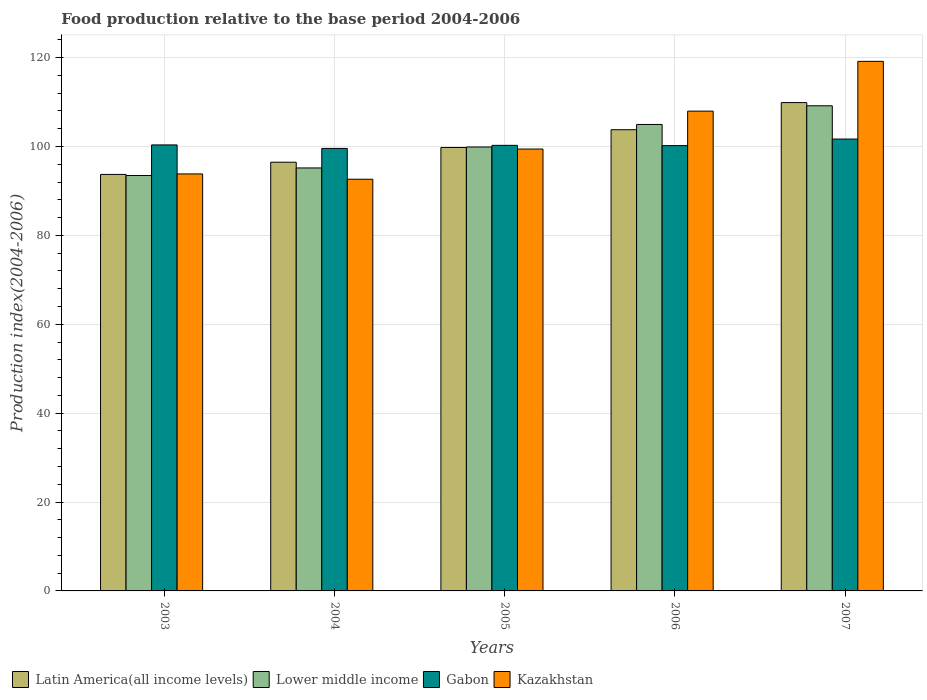How many different coloured bars are there?
Provide a short and direct response. 4. How many groups of bars are there?
Make the answer very short. 5. Are the number of bars per tick equal to the number of legend labels?
Offer a terse response. Yes. Are the number of bars on each tick of the X-axis equal?
Your answer should be compact. Yes. What is the food production index in Latin America(all income levels) in 2003?
Keep it short and to the point. 93.71. Across all years, what is the maximum food production index in Kazakhstan?
Provide a short and direct response. 119.15. Across all years, what is the minimum food production index in Gabon?
Offer a very short reply. 99.56. In which year was the food production index in Kazakhstan maximum?
Your answer should be compact. 2007. In which year was the food production index in Kazakhstan minimum?
Ensure brevity in your answer.  2004. What is the total food production index in Lower middle income in the graph?
Offer a terse response. 502.62. What is the difference between the food production index in Gabon in 2003 and that in 2005?
Keep it short and to the point. 0.1. What is the difference between the food production index in Latin America(all income levels) in 2005 and the food production index in Lower middle income in 2004?
Keep it short and to the point. 4.61. What is the average food production index in Latin America(all income levels) per year?
Make the answer very short. 100.72. In the year 2005, what is the difference between the food production index in Kazakhstan and food production index in Lower middle income?
Give a very brief answer. -0.46. What is the ratio of the food production index in Gabon in 2004 to that in 2007?
Your answer should be very brief. 0.98. Is the food production index in Lower middle income in 2004 less than that in 2005?
Make the answer very short. Yes. What is the difference between the highest and the second highest food production index in Kazakhstan?
Make the answer very short. 11.2. What is the difference between the highest and the lowest food production index in Kazakhstan?
Your response must be concise. 26.52. Is the sum of the food production index in Gabon in 2003 and 2005 greater than the maximum food production index in Latin America(all income levels) across all years?
Your response must be concise. Yes. Is it the case that in every year, the sum of the food production index in Latin America(all income levels) and food production index in Lower middle income is greater than the sum of food production index in Kazakhstan and food production index in Gabon?
Offer a terse response. No. What does the 4th bar from the left in 2005 represents?
Your answer should be compact. Kazakhstan. What does the 3rd bar from the right in 2004 represents?
Your response must be concise. Lower middle income. How many bars are there?
Provide a succinct answer. 20. Are all the bars in the graph horizontal?
Your response must be concise. No. How are the legend labels stacked?
Your answer should be very brief. Horizontal. What is the title of the graph?
Offer a terse response. Food production relative to the base period 2004-2006. Does "Guyana" appear as one of the legend labels in the graph?
Ensure brevity in your answer.  No. What is the label or title of the X-axis?
Ensure brevity in your answer.  Years. What is the label or title of the Y-axis?
Give a very brief answer. Production index(2004-2006). What is the Production index(2004-2006) of Latin America(all income levels) in 2003?
Provide a short and direct response. 93.71. What is the Production index(2004-2006) in Lower middle income in 2003?
Make the answer very short. 93.47. What is the Production index(2004-2006) of Gabon in 2003?
Your answer should be compact. 100.35. What is the Production index(2004-2006) of Kazakhstan in 2003?
Your answer should be very brief. 93.82. What is the Production index(2004-2006) of Latin America(all income levels) in 2004?
Provide a succinct answer. 96.46. What is the Production index(2004-2006) of Lower middle income in 2004?
Your answer should be very brief. 95.17. What is the Production index(2004-2006) in Gabon in 2004?
Your response must be concise. 99.56. What is the Production index(2004-2006) in Kazakhstan in 2004?
Your answer should be very brief. 92.63. What is the Production index(2004-2006) of Latin America(all income levels) in 2005?
Your answer should be very brief. 99.77. What is the Production index(2004-2006) in Lower middle income in 2005?
Provide a succinct answer. 99.88. What is the Production index(2004-2006) of Gabon in 2005?
Offer a terse response. 100.25. What is the Production index(2004-2006) of Kazakhstan in 2005?
Your response must be concise. 99.42. What is the Production index(2004-2006) of Latin America(all income levels) in 2006?
Provide a succinct answer. 103.77. What is the Production index(2004-2006) in Lower middle income in 2006?
Offer a terse response. 104.95. What is the Production index(2004-2006) of Gabon in 2006?
Your answer should be very brief. 100.19. What is the Production index(2004-2006) in Kazakhstan in 2006?
Offer a very short reply. 107.95. What is the Production index(2004-2006) of Latin America(all income levels) in 2007?
Ensure brevity in your answer.  109.87. What is the Production index(2004-2006) of Lower middle income in 2007?
Keep it short and to the point. 109.15. What is the Production index(2004-2006) in Gabon in 2007?
Offer a terse response. 101.67. What is the Production index(2004-2006) of Kazakhstan in 2007?
Provide a succinct answer. 119.15. Across all years, what is the maximum Production index(2004-2006) in Latin America(all income levels)?
Ensure brevity in your answer.  109.87. Across all years, what is the maximum Production index(2004-2006) of Lower middle income?
Make the answer very short. 109.15. Across all years, what is the maximum Production index(2004-2006) in Gabon?
Provide a succinct answer. 101.67. Across all years, what is the maximum Production index(2004-2006) of Kazakhstan?
Your answer should be compact. 119.15. Across all years, what is the minimum Production index(2004-2006) in Latin America(all income levels)?
Keep it short and to the point. 93.71. Across all years, what is the minimum Production index(2004-2006) in Lower middle income?
Offer a very short reply. 93.47. Across all years, what is the minimum Production index(2004-2006) of Gabon?
Your response must be concise. 99.56. Across all years, what is the minimum Production index(2004-2006) of Kazakhstan?
Ensure brevity in your answer.  92.63. What is the total Production index(2004-2006) of Latin America(all income levels) in the graph?
Make the answer very short. 503.59. What is the total Production index(2004-2006) in Lower middle income in the graph?
Offer a terse response. 502.62. What is the total Production index(2004-2006) in Gabon in the graph?
Your response must be concise. 502.02. What is the total Production index(2004-2006) in Kazakhstan in the graph?
Provide a succinct answer. 512.97. What is the difference between the Production index(2004-2006) in Latin America(all income levels) in 2003 and that in 2004?
Keep it short and to the point. -2.74. What is the difference between the Production index(2004-2006) in Gabon in 2003 and that in 2004?
Your answer should be compact. 0.79. What is the difference between the Production index(2004-2006) of Kazakhstan in 2003 and that in 2004?
Your response must be concise. 1.19. What is the difference between the Production index(2004-2006) in Latin America(all income levels) in 2003 and that in 2005?
Give a very brief answer. -6.06. What is the difference between the Production index(2004-2006) of Lower middle income in 2003 and that in 2005?
Ensure brevity in your answer.  -6.41. What is the difference between the Production index(2004-2006) in Latin America(all income levels) in 2003 and that in 2006?
Offer a terse response. -10.06. What is the difference between the Production index(2004-2006) of Lower middle income in 2003 and that in 2006?
Your response must be concise. -11.49. What is the difference between the Production index(2004-2006) in Gabon in 2003 and that in 2006?
Give a very brief answer. 0.16. What is the difference between the Production index(2004-2006) in Kazakhstan in 2003 and that in 2006?
Provide a succinct answer. -14.13. What is the difference between the Production index(2004-2006) of Latin America(all income levels) in 2003 and that in 2007?
Offer a terse response. -16.16. What is the difference between the Production index(2004-2006) in Lower middle income in 2003 and that in 2007?
Keep it short and to the point. -15.69. What is the difference between the Production index(2004-2006) of Gabon in 2003 and that in 2007?
Ensure brevity in your answer.  -1.32. What is the difference between the Production index(2004-2006) of Kazakhstan in 2003 and that in 2007?
Provide a succinct answer. -25.33. What is the difference between the Production index(2004-2006) in Latin America(all income levels) in 2004 and that in 2005?
Provide a short and direct response. -3.32. What is the difference between the Production index(2004-2006) of Lower middle income in 2004 and that in 2005?
Provide a short and direct response. -4.71. What is the difference between the Production index(2004-2006) in Gabon in 2004 and that in 2005?
Provide a short and direct response. -0.69. What is the difference between the Production index(2004-2006) of Kazakhstan in 2004 and that in 2005?
Offer a terse response. -6.79. What is the difference between the Production index(2004-2006) in Latin America(all income levels) in 2004 and that in 2006?
Your answer should be compact. -7.31. What is the difference between the Production index(2004-2006) in Lower middle income in 2004 and that in 2006?
Provide a short and direct response. -9.79. What is the difference between the Production index(2004-2006) in Gabon in 2004 and that in 2006?
Keep it short and to the point. -0.63. What is the difference between the Production index(2004-2006) in Kazakhstan in 2004 and that in 2006?
Offer a very short reply. -15.32. What is the difference between the Production index(2004-2006) in Latin America(all income levels) in 2004 and that in 2007?
Provide a short and direct response. -13.42. What is the difference between the Production index(2004-2006) in Lower middle income in 2004 and that in 2007?
Give a very brief answer. -13.99. What is the difference between the Production index(2004-2006) of Gabon in 2004 and that in 2007?
Provide a succinct answer. -2.11. What is the difference between the Production index(2004-2006) in Kazakhstan in 2004 and that in 2007?
Make the answer very short. -26.52. What is the difference between the Production index(2004-2006) of Latin America(all income levels) in 2005 and that in 2006?
Offer a very short reply. -4. What is the difference between the Production index(2004-2006) of Lower middle income in 2005 and that in 2006?
Ensure brevity in your answer.  -5.07. What is the difference between the Production index(2004-2006) of Gabon in 2005 and that in 2006?
Provide a succinct answer. 0.06. What is the difference between the Production index(2004-2006) of Kazakhstan in 2005 and that in 2006?
Ensure brevity in your answer.  -8.53. What is the difference between the Production index(2004-2006) of Latin America(all income levels) in 2005 and that in 2007?
Your answer should be compact. -10.1. What is the difference between the Production index(2004-2006) of Lower middle income in 2005 and that in 2007?
Offer a very short reply. -9.27. What is the difference between the Production index(2004-2006) in Gabon in 2005 and that in 2007?
Your answer should be very brief. -1.42. What is the difference between the Production index(2004-2006) in Kazakhstan in 2005 and that in 2007?
Offer a very short reply. -19.73. What is the difference between the Production index(2004-2006) of Latin America(all income levels) in 2006 and that in 2007?
Provide a short and direct response. -6.1. What is the difference between the Production index(2004-2006) in Lower middle income in 2006 and that in 2007?
Ensure brevity in your answer.  -4.2. What is the difference between the Production index(2004-2006) in Gabon in 2006 and that in 2007?
Ensure brevity in your answer.  -1.48. What is the difference between the Production index(2004-2006) of Kazakhstan in 2006 and that in 2007?
Offer a terse response. -11.2. What is the difference between the Production index(2004-2006) of Latin America(all income levels) in 2003 and the Production index(2004-2006) of Lower middle income in 2004?
Offer a terse response. -1.45. What is the difference between the Production index(2004-2006) of Latin America(all income levels) in 2003 and the Production index(2004-2006) of Gabon in 2004?
Your answer should be very brief. -5.85. What is the difference between the Production index(2004-2006) of Latin America(all income levels) in 2003 and the Production index(2004-2006) of Kazakhstan in 2004?
Ensure brevity in your answer.  1.08. What is the difference between the Production index(2004-2006) of Lower middle income in 2003 and the Production index(2004-2006) of Gabon in 2004?
Keep it short and to the point. -6.09. What is the difference between the Production index(2004-2006) in Lower middle income in 2003 and the Production index(2004-2006) in Kazakhstan in 2004?
Provide a short and direct response. 0.84. What is the difference between the Production index(2004-2006) of Gabon in 2003 and the Production index(2004-2006) of Kazakhstan in 2004?
Your response must be concise. 7.72. What is the difference between the Production index(2004-2006) of Latin America(all income levels) in 2003 and the Production index(2004-2006) of Lower middle income in 2005?
Provide a short and direct response. -6.17. What is the difference between the Production index(2004-2006) in Latin America(all income levels) in 2003 and the Production index(2004-2006) in Gabon in 2005?
Your response must be concise. -6.54. What is the difference between the Production index(2004-2006) in Latin America(all income levels) in 2003 and the Production index(2004-2006) in Kazakhstan in 2005?
Your response must be concise. -5.71. What is the difference between the Production index(2004-2006) in Lower middle income in 2003 and the Production index(2004-2006) in Gabon in 2005?
Make the answer very short. -6.78. What is the difference between the Production index(2004-2006) in Lower middle income in 2003 and the Production index(2004-2006) in Kazakhstan in 2005?
Offer a terse response. -5.95. What is the difference between the Production index(2004-2006) of Gabon in 2003 and the Production index(2004-2006) of Kazakhstan in 2005?
Your response must be concise. 0.93. What is the difference between the Production index(2004-2006) in Latin America(all income levels) in 2003 and the Production index(2004-2006) in Lower middle income in 2006?
Your answer should be very brief. -11.24. What is the difference between the Production index(2004-2006) of Latin America(all income levels) in 2003 and the Production index(2004-2006) of Gabon in 2006?
Your response must be concise. -6.48. What is the difference between the Production index(2004-2006) of Latin America(all income levels) in 2003 and the Production index(2004-2006) of Kazakhstan in 2006?
Provide a short and direct response. -14.24. What is the difference between the Production index(2004-2006) in Lower middle income in 2003 and the Production index(2004-2006) in Gabon in 2006?
Your answer should be compact. -6.72. What is the difference between the Production index(2004-2006) in Lower middle income in 2003 and the Production index(2004-2006) in Kazakhstan in 2006?
Your answer should be very brief. -14.48. What is the difference between the Production index(2004-2006) of Gabon in 2003 and the Production index(2004-2006) of Kazakhstan in 2006?
Give a very brief answer. -7.6. What is the difference between the Production index(2004-2006) of Latin America(all income levels) in 2003 and the Production index(2004-2006) of Lower middle income in 2007?
Your answer should be very brief. -15.44. What is the difference between the Production index(2004-2006) in Latin America(all income levels) in 2003 and the Production index(2004-2006) in Gabon in 2007?
Keep it short and to the point. -7.96. What is the difference between the Production index(2004-2006) of Latin America(all income levels) in 2003 and the Production index(2004-2006) of Kazakhstan in 2007?
Offer a very short reply. -25.44. What is the difference between the Production index(2004-2006) in Lower middle income in 2003 and the Production index(2004-2006) in Gabon in 2007?
Provide a succinct answer. -8.2. What is the difference between the Production index(2004-2006) of Lower middle income in 2003 and the Production index(2004-2006) of Kazakhstan in 2007?
Provide a short and direct response. -25.68. What is the difference between the Production index(2004-2006) in Gabon in 2003 and the Production index(2004-2006) in Kazakhstan in 2007?
Provide a succinct answer. -18.8. What is the difference between the Production index(2004-2006) in Latin America(all income levels) in 2004 and the Production index(2004-2006) in Lower middle income in 2005?
Offer a very short reply. -3.42. What is the difference between the Production index(2004-2006) in Latin America(all income levels) in 2004 and the Production index(2004-2006) in Gabon in 2005?
Provide a short and direct response. -3.79. What is the difference between the Production index(2004-2006) in Latin America(all income levels) in 2004 and the Production index(2004-2006) in Kazakhstan in 2005?
Ensure brevity in your answer.  -2.96. What is the difference between the Production index(2004-2006) in Lower middle income in 2004 and the Production index(2004-2006) in Gabon in 2005?
Your answer should be very brief. -5.08. What is the difference between the Production index(2004-2006) of Lower middle income in 2004 and the Production index(2004-2006) of Kazakhstan in 2005?
Offer a terse response. -4.25. What is the difference between the Production index(2004-2006) in Gabon in 2004 and the Production index(2004-2006) in Kazakhstan in 2005?
Give a very brief answer. 0.14. What is the difference between the Production index(2004-2006) in Latin America(all income levels) in 2004 and the Production index(2004-2006) in Lower middle income in 2006?
Give a very brief answer. -8.5. What is the difference between the Production index(2004-2006) in Latin America(all income levels) in 2004 and the Production index(2004-2006) in Gabon in 2006?
Give a very brief answer. -3.73. What is the difference between the Production index(2004-2006) in Latin America(all income levels) in 2004 and the Production index(2004-2006) in Kazakhstan in 2006?
Give a very brief answer. -11.49. What is the difference between the Production index(2004-2006) in Lower middle income in 2004 and the Production index(2004-2006) in Gabon in 2006?
Provide a succinct answer. -5.02. What is the difference between the Production index(2004-2006) in Lower middle income in 2004 and the Production index(2004-2006) in Kazakhstan in 2006?
Offer a terse response. -12.78. What is the difference between the Production index(2004-2006) in Gabon in 2004 and the Production index(2004-2006) in Kazakhstan in 2006?
Keep it short and to the point. -8.39. What is the difference between the Production index(2004-2006) of Latin America(all income levels) in 2004 and the Production index(2004-2006) of Lower middle income in 2007?
Your answer should be compact. -12.7. What is the difference between the Production index(2004-2006) of Latin America(all income levels) in 2004 and the Production index(2004-2006) of Gabon in 2007?
Give a very brief answer. -5.21. What is the difference between the Production index(2004-2006) in Latin America(all income levels) in 2004 and the Production index(2004-2006) in Kazakhstan in 2007?
Offer a very short reply. -22.69. What is the difference between the Production index(2004-2006) in Lower middle income in 2004 and the Production index(2004-2006) in Gabon in 2007?
Your response must be concise. -6.5. What is the difference between the Production index(2004-2006) of Lower middle income in 2004 and the Production index(2004-2006) of Kazakhstan in 2007?
Provide a short and direct response. -23.98. What is the difference between the Production index(2004-2006) of Gabon in 2004 and the Production index(2004-2006) of Kazakhstan in 2007?
Your answer should be compact. -19.59. What is the difference between the Production index(2004-2006) of Latin America(all income levels) in 2005 and the Production index(2004-2006) of Lower middle income in 2006?
Your answer should be compact. -5.18. What is the difference between the Production index(2004-2006) in Latin America(all income levels) in 2005 and the Production index(2004-2006) in Gabon in 2006?
Keep it short and to the point. -0.42. What is the difference between the Production index(2004-2006) in Latin America(all income levels) in 2005 and the Production index(2004-2006) in Kazakhstan in 2006?
Your answer should be very brief. -8.18. What is the difference between the Production index(2004-2006) in Lower middle income in 2005 and the Production index(2004-2006) in Gabon in 2006?
Offer a very short reply. -0.31. What is the difference between the Production index(2004-2006) of Lower middle income in 2005 and the Production index(2004-2006) of Kazakhstan in 2006?
Keep it short and to the point. -8.07. What is the difference between the Production index(2004-2006) in Gabon in 2005 and the Production index(2004-2006) in Kazakhstan in 2006?
Offer a terse response. -7.7. What is the difference between the Production index(2004-2006) in Latin America(all income levels) in 2005 and the Production index(2004-2006) in Lower middle income in 2007?
Offer a terse response. -9.38. What is the difference between the Production index(2004-2006) of Latin America(all income levels) in 2005 and the Production index(2004-2006) of Gabon in 2007?
Your answer should be compact. -1.9. What is the difference between the Production index(2004-2006) of Latin America(all income levels) in 2005 and the Production index(2004-2006) of Kazakhstan in 2007?
Your answer should be compact. -19.38. What is the difference between the Production index(2004-2006) of Lower middle income in 2005 and the Production index(2004-2006) of Gabon in 2007?
Offer a terse response. -1.79. What is the difference between the Production index(2004-2006) in Lower middle income in 2005 and the Production index(2004-2006) in Kazakhstan in 2007?
Your answer should be compact. -19.27. What is the difference between the Production index(2004-2006) of Gabon in 2005 and the Production index(2004-2006) of Kazakhstan in 2007?
Your response must be concise. -18.9. What is the difference between the Production index(2004-2006) of Latin America(all income levels) in 2006 and the Production index(2004-2006) of Lower middle income in 2007?
Offer a very short reply. -5.38. What is the difference between the Production index(2004-2006) in Latin America(all income levels) in 2006 and the Production index(2004-2006) in Gabon in 2007?
Your response must be concise. 2.1. What is the difference between the Production index(2004-2006) in Latin America(all income levels) in 2006 and the Production index(2004-2006) in Kazakhstan in 2007?
Make the answer very short. -15.38. What is the difference between the Production index(2004-2006) of Lower middle income in 2006 and the Production index(2004-2006) of Gabon in 2007?
Offer a terse response. 3.28. What is the difference between the Production index(2004-2006) of Lower middle income in 2006 and the Production index(2004-2006) of Kazakhstan in 2007?
Make the answer very short. -14.2. What is the difference between the Production index(2004-2006) in Gabon in 2006 and the Production index(2004-2006) in Kazakhstan in 2007?
Provide a succinct answer. -18.96. What is the average Production index(2004-2006) of Latin America(all income levels) per year?
Provide a short and direct response. 100.72. What is the average Production index(2004-2006) in Lower middle income per year?
Keep it short and to the point. 100.52. What is the average Production index(2004-2006) of Gabon per year?
Ensure brevity in your answer.  100.4. What is the average Production index(2004-2006) in Kazakhstan per year?
Provide a succinct answer. 102.59. In the year 2003, what is the difference between the Production index(2004-2006) in Latin America(all income levels) and Production index(2004-2006) in Lower middle income?
Your response must be concise. 0.25. In the year 2003, what is the difference between the Production index(2004-2006) of Latin America(all income levels) and Production index(2004-2006) of Gabon?
Keep it short and to the point. -6.64. In the year 2003, what is the difference between the Production index(2004-2006) of Latin America(all income levels) and Production index(2004-2006) of Kazakhstan?
Make the answer very short. -0.11. In the year 2003, what is the difference between the Production index(2004-2006) of Lower middle income and Production index(2004-2006) of Gabon?
Your answer should be very brief. -6.88. In the year 2003, what is the difference between the Production index(2004-2006) of Lower middle income and Production index(2004-2006) of Kazakhstan?
Your answer should be very brief. -0.35. In the year 2003, what is the difference between the Production index(2004-2006) of Gabon and Production index(2004-2006) of Kazakhstan?
Make the answer very short. 6.53. In the year 2004, what is the difference between the Production index(2004-2006) in Latin America(all income levels) and Production index(2004-2006) in Lower middle income?
Offer a very short reply. 1.29. In the year 2004, what is the difference between the Production index(2004-2006) of Latin America(all income levels) and Production index(2004-2006) of Gabon?
Your response must be concise. -3.1. In the year 2004, what is the difference between the Production index(2004-2006) of Latin America(all income levels) and Production index(2004-2006) of Kazakhstan?
Offer a terse response. 3.83. In the year 2004, what is the difference between the Production index(2004-2006) in Lower middle income and Production index(2004-2006) in Gabon?
Provide a short and direct response. -4.39. In the year 2004, what is the difference between the Production index(2004-2006) in Lower middle income and Production index(2004-2006) in Kazakhstan?
Provide a short and direct response. 2.54. In the year 2004, what is the difference between the Production index(2004-2006) in Gabon and Production index(2004-2006) in Kazakhstan?
Provide a short and direct response. 6.93. In the year 2005, what is the difference between the Production index(2004-2006) of Latin America(all income levels) and Production index(2004-2006) of Lower middle income?
Your response must be concise. -0.11. In the year 2005, what is the difference between the Production index(2004-2006) in Latin America(all income levels) and Production index(2004-2006) in Gabon?
Your answer should be very brief. -0.48. In the year 2005, what is the difference between the Production index(2004-2006) of Latin America(all income levels) and Production index(2004-2006) of Kazakhstan?
Keep it short and to the point. 0.35. In the year 2005, what is the difference between the Production index(2004-2006) of Lower middle income and Production index(2004-2006) of Gabon?
Make the answer very short. -0.37. In the year 2005, what is the difference between the Production index(2004-2006) in Lower middle income and Production index(2004-2006) in Kazakhstan?
Keep it short and to the point. 0.46. In the year 2005, what is the difference between the Production index(2004-2006) of Gabon and Production index(2004-2006) of Kazakhstan?
Give a very brief answer. 0.83. In the year 2006, what is the difference between the Production index(2004-2006) in Latin America(all income levels) and Production index(2004-2006) in Lower middle income?
Provide a short and direct response. -1.18. In the year 2006, what is the difference between the Production index(2004-2006) of Latin America(all income levels) and Production index(2004-2006) of Gabon?
Make the answer very short. 3.58. In the year 2006, what is the difference between the Production index(2004-2006) of Latin America(all income levels) and Production index(2004-2006) of Kazakhstan?
Your answer should be very brief. -4.18. In the year 2006, what is the difference between the Production index(2004-2006) of Lower middle income and Production index(2004-2006) of Gabon?
Make the answer very short. 4.76. In the year 2006, what is the difference between the Production index(2004-2006) of Lower middle income and Production index(2004-2006) of Kazakhstan?
Offer a very short reply. -3. In the year 2006, what is the difference between the Production index(2004-2006) in Gabon and Production index(2004-2006) in Kazakhstan?
Your response must be concise. -7.76. In the year 2007, what is the difference between the Production index(2004-2006) of Latin America(all income levels) and Production index(2004-2006) of Lower middle income?
Offer a very short reply. 0.72. In the year 2007, what is the difference between the Production index(2004-2006) of Latin America(all income levels) and Production index(2004-2006) of Gabon?
Offer a terse response. 8.2. In the year 2007, what is the difference between the Production index(2004-2006) in Latin America(all income levels) and Production index(2004-2006) in Kazakhstan?
Give a very brief answer. -9.28. In the year 2007, what is the difference between the Production index(2004-2006) of Lower middle income and Production index(2004-2006) of Gabon?
Provide a short and direct response. 7.48. In the year 2007, what is the difference between the Production index(2004-2006) in Lower middle income and Production index(2004-2006) in Kazakhstan?
Provide a short and direct response. -10. In the year 2007, what is the difference between the Production index(2004-2006) of Gabon and Production index(2004-2006) of Kazakhstan?
Ensure brevity in your answer.  -17.48. What is the ratio of the Production index(2004-2006) in Latin America(all income levels) in 2003 to that in 2004?
Ensure brevity in your answer.  0.97. What is the ratio of the Production index(2004-2006) in Lower middle income in 2003 to that in 2004?
Your answer should be compact. 0.98. What is the ratio of the Production index(2004-2006) in Gabon in 2003 to that in 2004?
Your answer should be very brief. 1.01. What is the ratio of the Production index(2004-2006) of Kazakhstan in 2003 to that in 2004?
Offer a very short reply. 1.01. What is the ratio of the Production index(2004-2006) of Latin America(all income levels) in 2003 to that in 2005?
Provide a short and direct response. 0.94. What is the ratio of the Production index(2004-2006) in Lower middle income in 2003 to that in 2005?
Your answer should be compact. 0.94. What is the ratio of the Production index(2004-2006) of Kazakhstan in 2003 to that in 2005?
Your answer should be compact. 0.94. What is the ratio of the Production index(2004-2006) in Latin America(all income levels) in 2003 to that in 2006?
Provide a short and direct response. 0.9. What is the ratio of the Production index(2004-2006) in Lower middle income in 2003 to that in 2006?
Keep it short and to the point. 0.89. What is the ratio of the Production index(2004-2006) of Gabon in 2003 to that in 2006?
Your answer should be very brief. 1. What is the ratio of the Production index(2004-2006) in Kazakhstan in 2003 to that in 2006?
Offer a very short reply. 0.87. What is the ratio of the Production index(2004-2006) in Latin America(all income levels) in 2003 to that in 2007?
Keep it short and to the point. 0.85. What is the ratio of the Production index(2004-2006) in Lower middle income in 2003 to that in 2007?
Your answer should be very brief. 0.86. What is the ratio of the Production index(2004-2006) in Kazakhstan in 2003 to that in 2007?
Offer a terse response. 0.79. What is the ratio of the Production index(2004-2006) of Latin America(all income levels) in 2004 to that in 2005?
Offer a terse response. 0.97. What is the ratio of the Production index(2004-2006) in Lower middle income in 2004 to that in 2005?
Keep it short and to the point. 0.95. What is the ratio of the Production index(2004-2006) in Kazakhstan in 2004 to that in 2005?
Ensure brevity in your answer.  0.93. What is the ratio of the Production index(2004-2006) in Latin America(all income levels) in 2004 to that in 2006?
Give a very brief answer. 0.93. What is the ratio of the Production index(2004-2006) in Lower middle income in 2004 to that in 2006?
Your response must be concise. 0.91. What is the ratio of the Production index(2004-2006) of Kazakhstan in 2004 to that in 2006?
Give a very brief answer. 0.86. What is the ratio of the Production index(2004-2006) in Latin America(all income levels) in 2004 to that in 2007?
Your answer should be very brief. 0.88. What is the ratio of the Production index(2004-2006) of Lower middle income in 2004 to that in 2007?
Keep it short and to the point. 0.87. What is the ratio of the Production index(2004-2006) of Gabon in 2004 to that in 2007?
Offer a terse response. 0.98. What is the ratio of the Production index(2004-2006) in Kazakhstan in 2004 to that in 2007?
Keep it short and to the point. 0.78. What is the ratio of the Production index(2004-2006) of Latin America(all income levels) in 2005 to that in 2006?
Your response must be concise. 0.96. What is the ratio of the Production index(2004-2006) in Lower middle income in 2005 to that in 2006?
Make the answer very short. 0.95. What is the ratio of the Production index(2004-2006) of Kazakhstan in 2005 to that in 2006?
Provide a short and direct response. 0.92. What is the ratio of the Production index(2004-2006) in Latin America(all income levels) in 2005 to that in 2007?
Give a very brief answer. 0.91. What is the ratio of the Production index(2004-2006) in Lower middle income in 2005 to that in 2007?
Your answer should be very brief. 0.92. What is the ratio of the Production index(2004-2006) in Gabon in 2005 to that in 2007?
Provide a short and direct response. 0.99. What is the ratio of the Production index(2004-2006) of Kazakhstan in 2005 to that in 2007?
Make the answer very short. 0.83. What is the ratio of the Production index(2004-2006) of Latin America(all income levels) in 2006 to that in 2007?
Your answer should be compact. 0.94. What is the ratio of the Production index(2004-2006) in Lower middle income in 2006 to that in 2007?
Your answer should be compact. 0.96. What is the ratio of the Production index(2004-2006) of Gabon in 2006 to that in 2007?
Provide a short and direct response. 0.99. What is the ratio of the Production index(2004-2006) of Kazakhstan in 2006 to that in 2007?
Provide a succinct answer. 0.91. What is the difference between the highest and the second highest Production index(2004-2006) in Latin America(all income levels)?
Your answer should be very brief. 6.1. What is the difference between the highest and the second highest Production index(2004-2006) in Lower middle income?
Offer a terse response. 4.2. What is the difference between the highest and the second highest Production index(2004-2006) of Gabon?
Give a very brief answer. 1.32. What is the difference between the highest and the lowest Production index(2004-2006) of Latin America(all income levels)?
Offer a terse response. 16.16. What is the difference between the highest and the lowest Production index(2004-2006) of Lower middle income?
Give a very brief answer. 15.69. What is the difference between the highest and the lowest Production index(2004-2006) in Gabon?
Keep it short and to the point. 2.11. What is the difference between the highest and the lowest Production index(2004-2006) in Kazakhstan?
Offer a terse response. 26.52. 